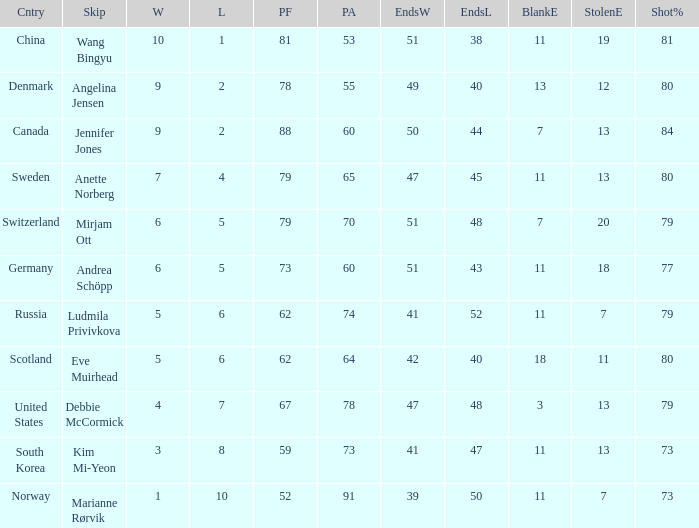When the country was Scotland, how many ends were won? 1.0. 